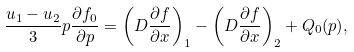Convert formula to latex. <formula><loc_0><loc_0><loc_500><loc_500>\frac { u _ { 1 } - u _ { 2 } } { 3 } p \frac { \partial f _ { 0 } } { \partial p } = \left ( D \frac { \partial f } { \partial x } \right ) _ { 1 } - \left ( D \frac { \partial f } { \partial x } \right ) _ { 2 } + Q _ { 0 } ( p ) ,</formula> 